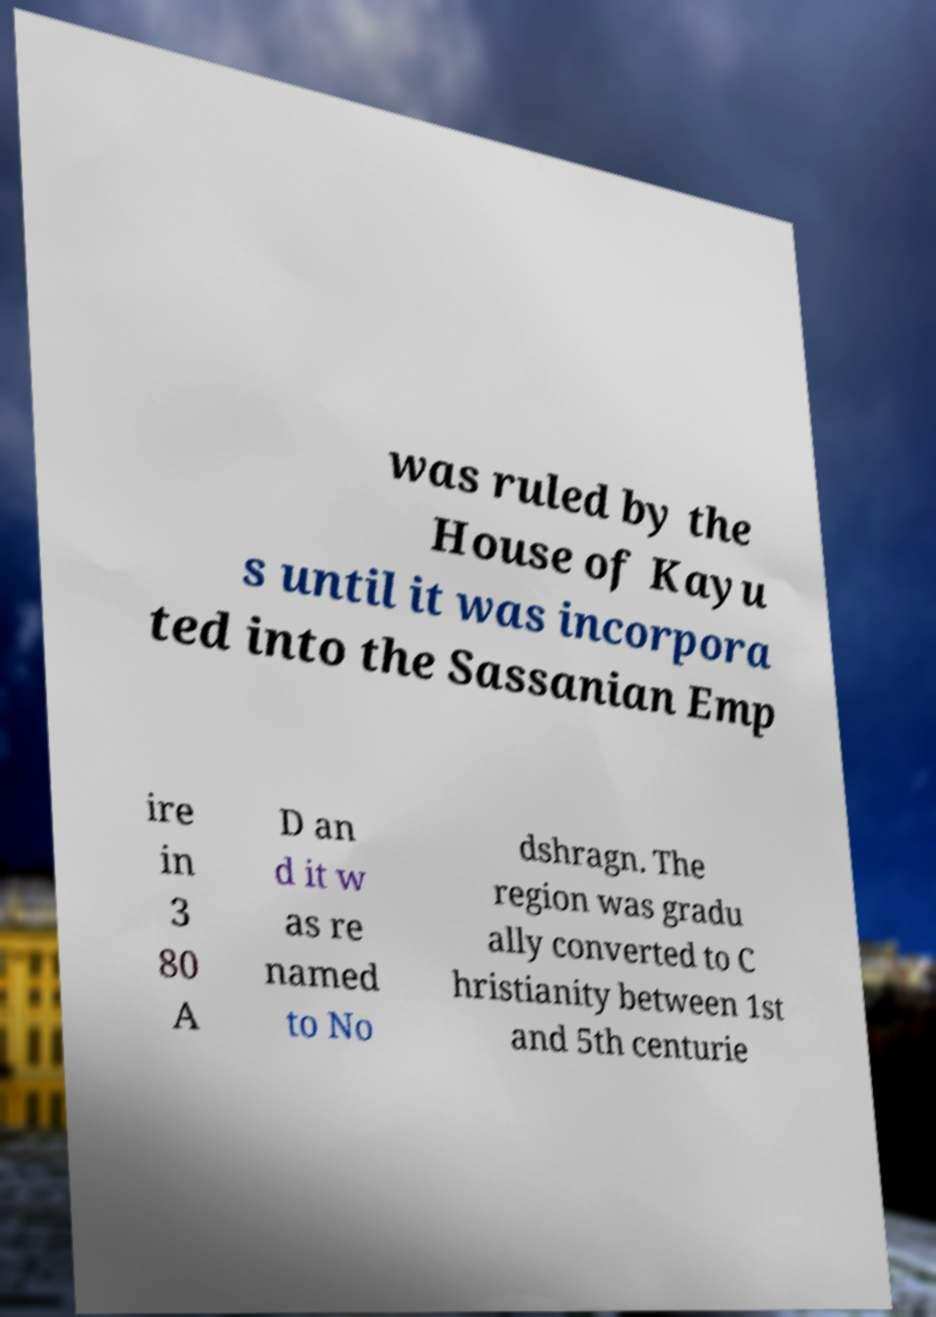Could you assist in decoding the text presented in this image and type it out clearly? was ruled by the House of Kayu s until it was incorpora ted into the Sassanian Emp ire in 3 80 A D an d it w as re named to No dshragn. The region was gradu ally converted to C hristianity between 1st and 5th centurie 